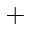Convert formula to latex. <formula><loc_0><loc_0><loc_500><loc_500>^ { + }</formula> 